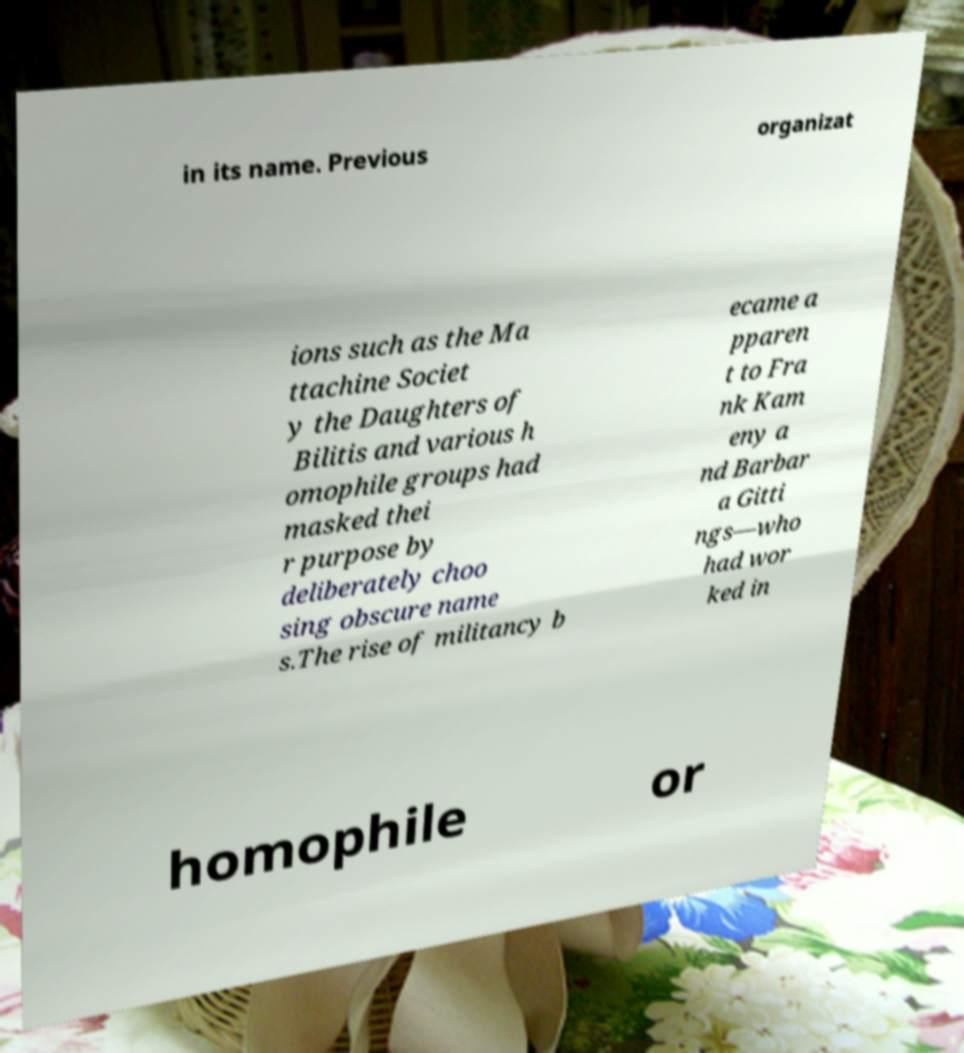Please read and relay the text visible in this image. What does it say? in its name. Previous organizat ions such as the Ma ttachine Societ y the Daughters of Bilitis and various h omophile groups had masked thei r purpose by deliberately choo sing obscure name s.The rise of militancy b ecame a pparen t to Fra nk Kam eny a nd Barbar a Gitti ngs—who had wor ked in homophile or 